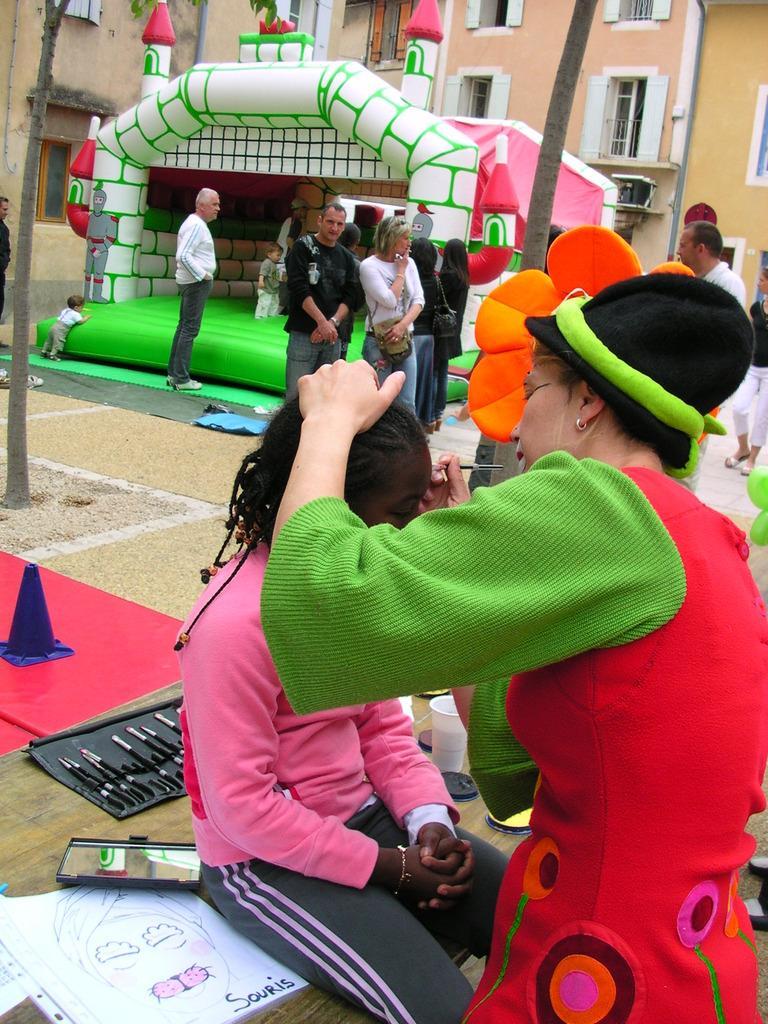In one or two sentences, can you explain what this image depicts? In this image I can see few people with different color dresses. To the back of these people I can see the air balloon which is in green and white color. In the back I can see the building and there are windows to it. And I can see one person is wearing the hat. 